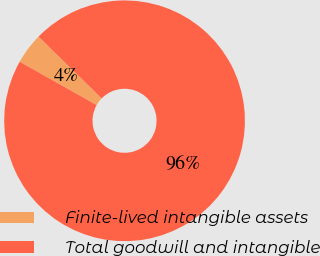Convert chart to OTSL. <chart><loc_0><loc_0><loc_500><loc_500><pie_chart><fcel>Finite-lived intangible assets<fcel>Total goodwill and intangible<nl><fcel>4.16%<fcel>95.84%<nl></chart> 